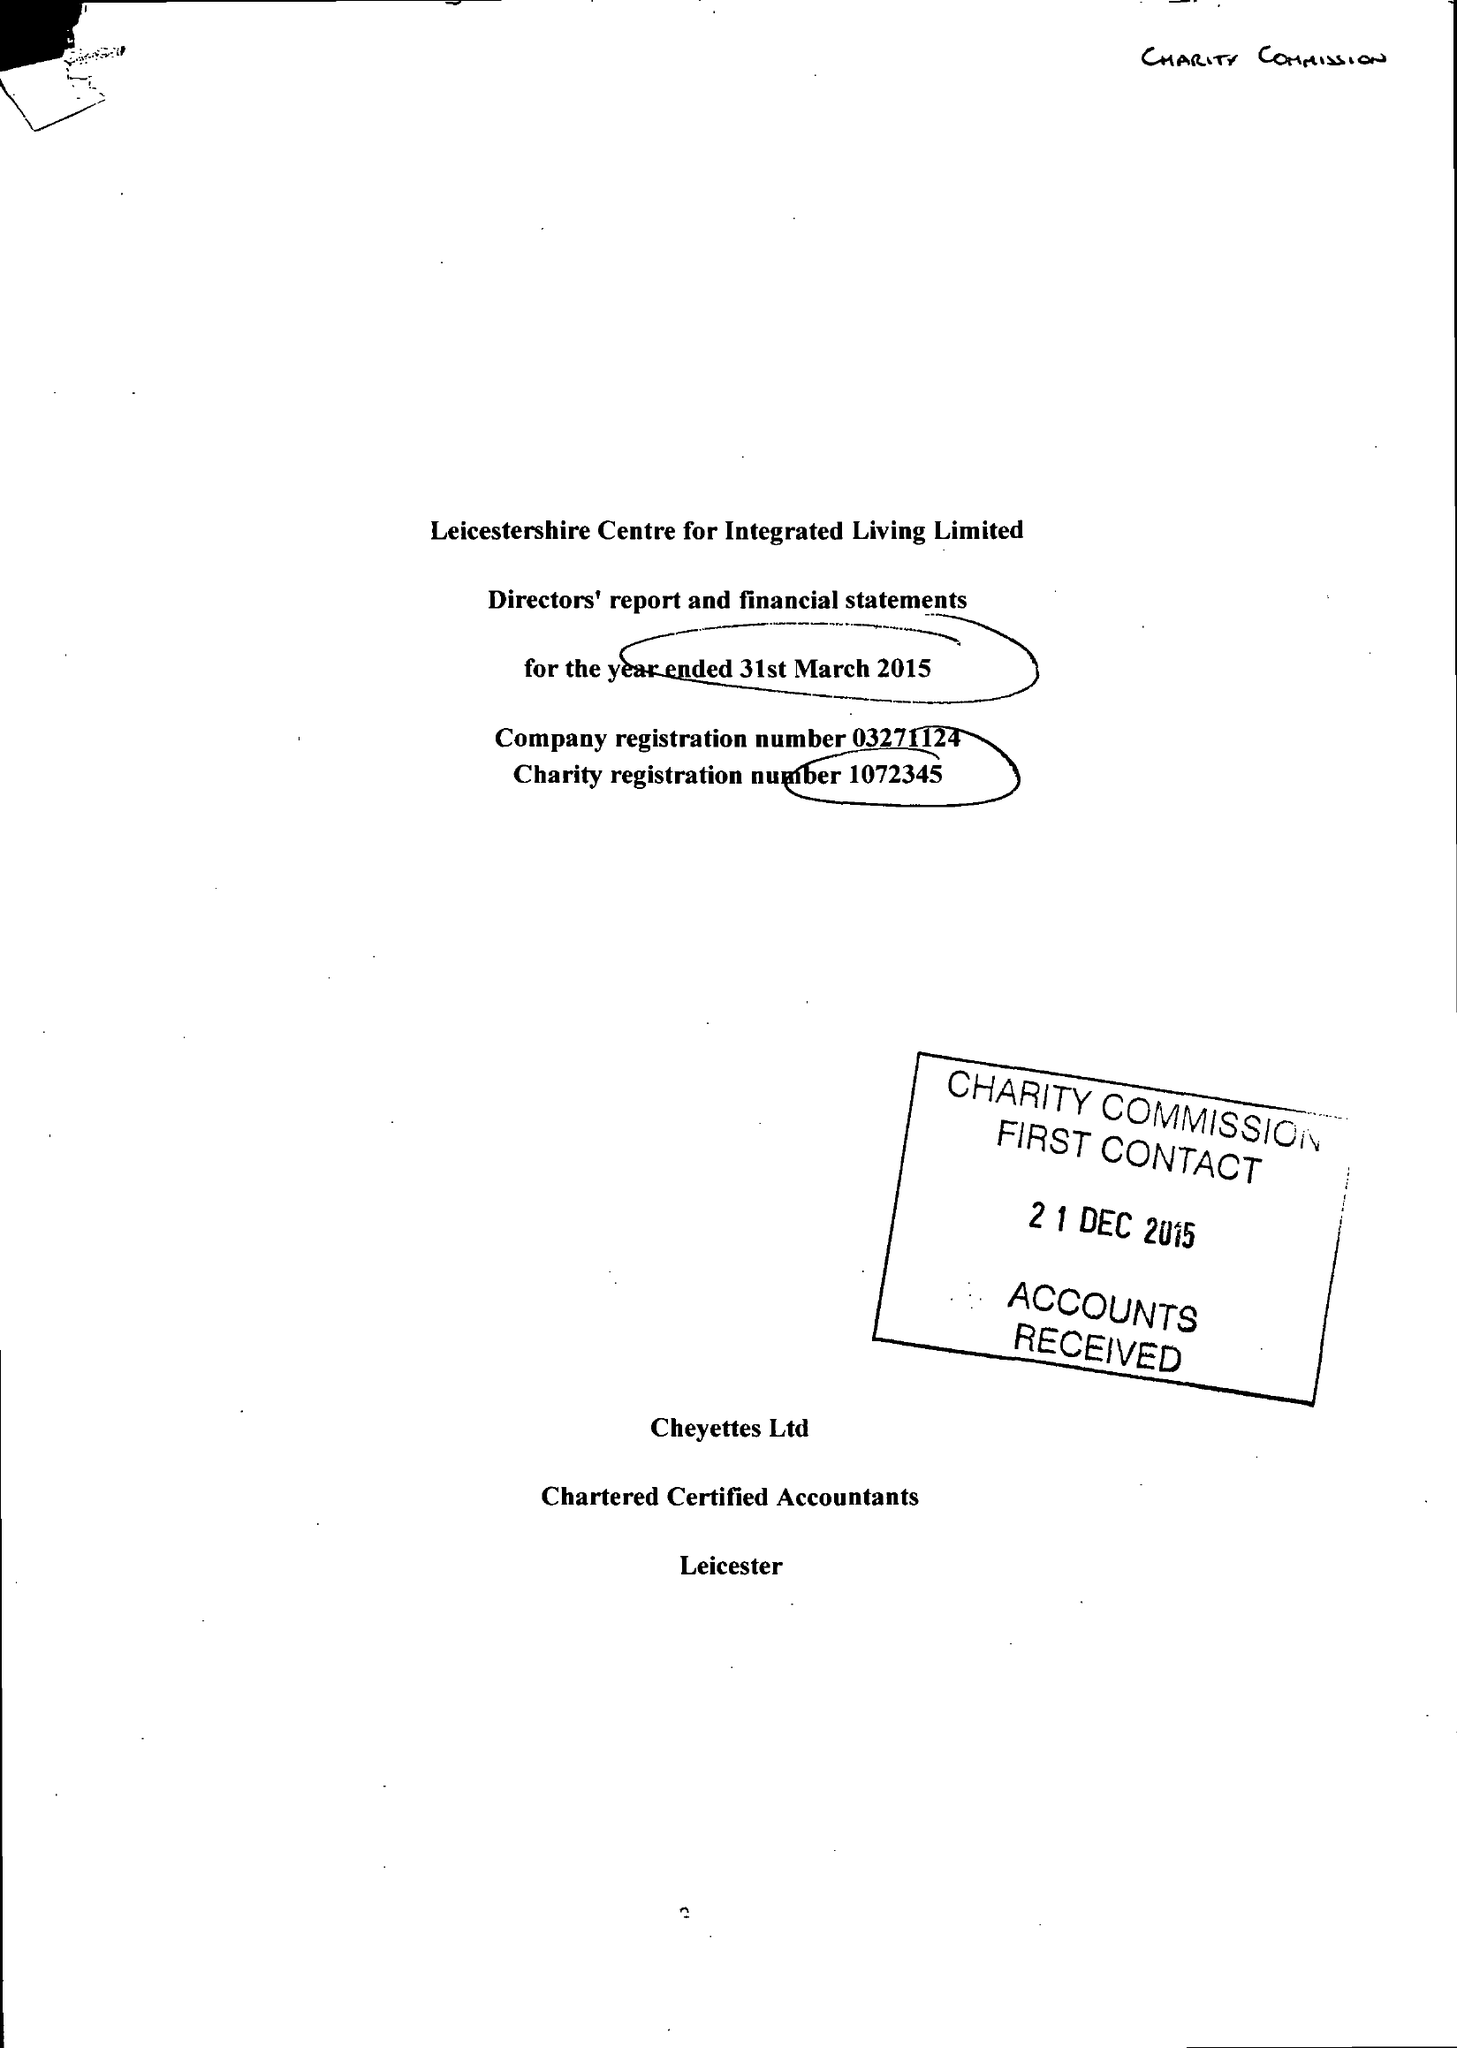What is the value for the address__postcode?
Answer the question using a single word or phrase. LE3 5PA 